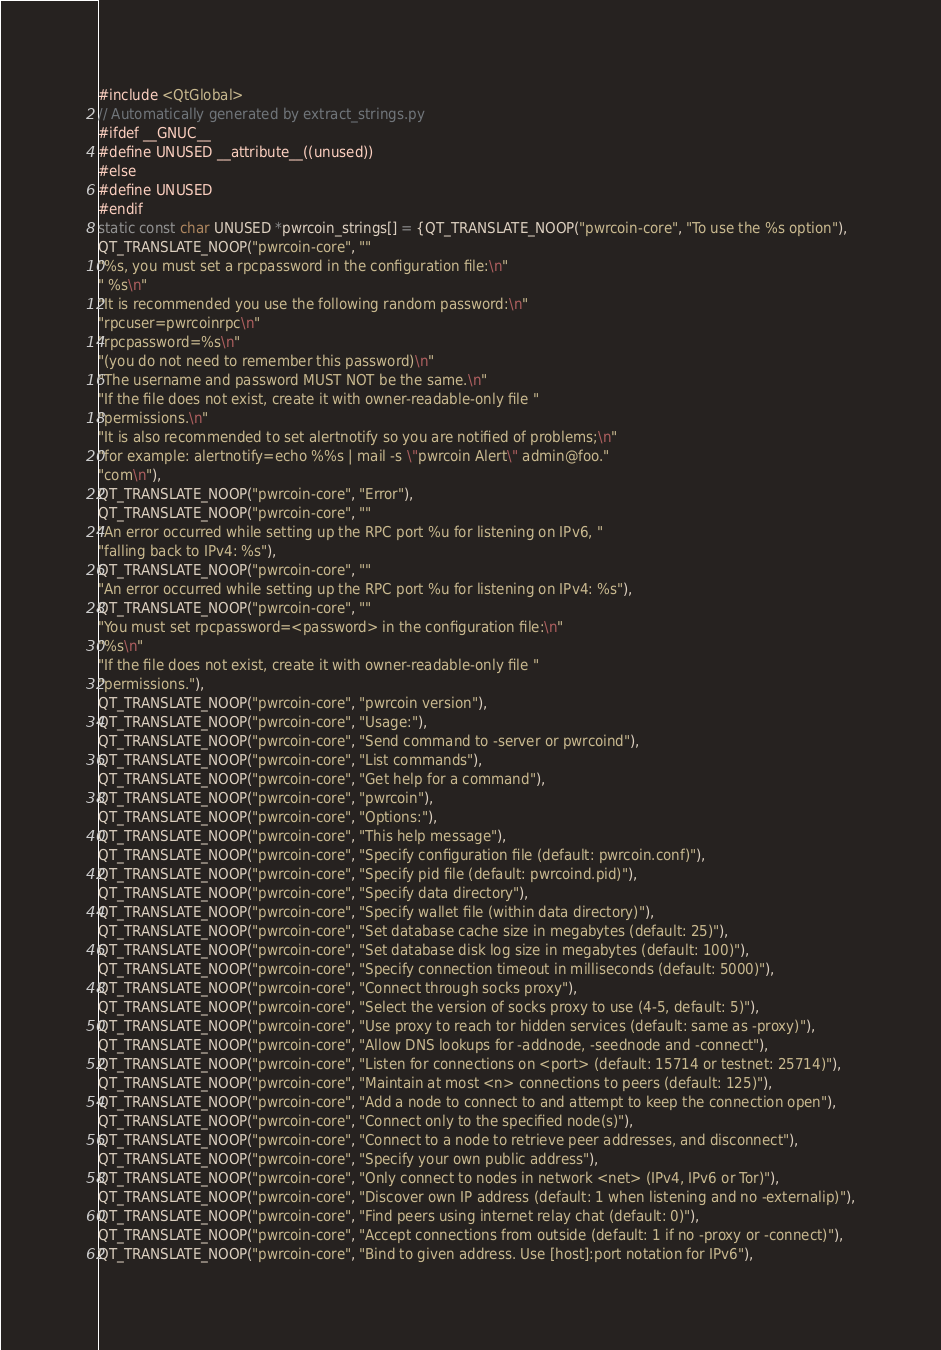<code> <loc_0><loc_0><loc_500><loc_500><_C++_>#include <QtGlobal>
// Automatically generated by extract_strings.py
#ifdef __GNUC__
#define UNUSED __attribute__((unused))
#else
#define UNUSED
#endif
static const char UNUSED *pwrcoin_strings[] = {QT_TRANSLATE_NOOP("pwrcoin-core", "To use the %s option"),
QT_TRANSLATE_NOOP("pwrcoin-core", ""
"%s, you must set a rpcpassword in the configuration file:\n"
" %s\n"
"It is recommended you use the following random password:\n"
"rpcuser=pwrcoinrpc\n"
"rpcpassword=%s\n"
"(you do not need to remember this password)\n"
"The username and password MUST NOT be the same.\n"
"If the file does not exist, create it with owner-readable-only file "
"permissions.\n"
"It is also recommended to set alertnotify so you are notified of problems;\n"
"for example: alertnotify=echo %%s | mail -s \"pwrcoin Alert\" admin@foo."
"com\n"),
QT_TRANSLATE_NOOP("pwrcoin-core", "Error"),
QT_TRANSLATE_NOOP("pwrcoin-core", ""
"An error occurred while setting up the RPC port %u for listening on IPv6, "
"falling back to IPv4: %s"),
QT_TRANSLATE_NOOP("pwrcoin-core", ""
"An error occurred while setting up the RPC port %u for listening on IPv4: %s"),
QT_TRANSLATE_NOOP("pwrcoin-core", ""
"You must set rpcpassword=<password> in the configuration file:\n"
"%s\n"
"If the file does not exist, create it with owner-readable-only file "
"permissions."),
QT_TRANSLATE_NOOP("pwrcoin-core", "pwrcoin version"),
QT_TRANSLATE_NOOP("pwrcoin-core", "Usage:"),
QT_TRANSLATE_NOOP("pwrcoin-core", "Send command to -server or pwrcoind"),
QT_TRANSLATE_NOOP("pwrcoin-core", "List commands"),
QT_TRANSLATE_NOOP("pwrcoin-core", "Get help for a command"),
QT_TRANSLATE_NOOP("pwrcoin-core", "pwrcoin"),
QT_TRANSLATE_NOOP("pwrcoin-core", "Options:"),
QT_TRANSLATE_NOOP("pwrcoin-core", "This help message"),
QT_TRANSLATE_NOOP("pwrcoin-core", "Specify configuration file (default: pwrcoin.conf)"),
QT_TRANSLATE_NOOP("pwrcoin-core", "Specify pid file (default: pwrcoind.pid)"),
QT_TRANSLATE_NOOP("pwrcoin-core", "Specify data directory"),
QT_TRANSLATE_NOOP("pwrcoin-core", "Specify wallet file (within data directory)"),
QT_TRANSLATE_NOOP("pwrcoin-core", "Set database cache size in megabytes (default: 25)"),
QT_TRANSLATE_NOOP("pwrcoin-core", "Set database disk log size in megabytes (default: 100)"),
QT_TRANSLATE_NOOP("pwrcoin-core", "Specify connection timeout in milliseconds (default: 5000)"),
QT_TRANSLATE_NOOP("pwrcoin-core", "Connect through socks proxy"),
QT_TRANSLATE_NOOP("pwrcoin-core", "Select the version of socks proxy to use (4-5, default: 5)"),
QT_TRANSLATE_NOOP("pwrcoin-core", "Use proxy to reach tor hidden services (default: same as -proxy)"),
QT_TRANSLATE_NOOP("pwrcoin-core", "Allow DNS lookups for -addnode, -seednode and -connect"),
QT_TRANSLATE_NOOP("pwrcoin-core", "Listen for connections on <port> (default: 15714 or testnet: 25714)"),
QT_TRANSLATE_NOOP("pwrcoin-core", "Maintain at most <n> connections to peers (default: 125)"),
QT_TRANSLATE_NOOP("pwrcoin-core", "Add a node to connect to and attempt to keep the connection open"),
QT_TRANSLATE_NOOP("pwrcoin-core", "Connect only to the specified node(s)"),
QT_TRANSLATE_NOOP("pwrcoin-core", "Connect to a node to retrieve peer addresses, and disconnect"),
QT_TRANSLATE_NOOP("pwrcoin-core", "Specify your own public address"),
QT_TRANSLATE_NOOP("pwrcoin-core", "Only connect to nodes in network <net> (IPv4, IPv6 or Tor)"),
QT_TRANSLATE_NOOP("pwrcoin-core", "Discover own IP address (default: 1 when listening and no -externalip)"),
QT_TRANSLATE_NOOP("pwrcoin-core", "Find peers using internet relay chat (default: 0)"),
QT_TRANSLATE_NOOP("pwrcoin-core", "Accept connections from outside (default: 1 if no -proxy or -connect)"),
QT_TRANSLATE_NOOP("pwrcoin-core", "Bind to given address. Use [host]:port notation for IPv6"),</code> 